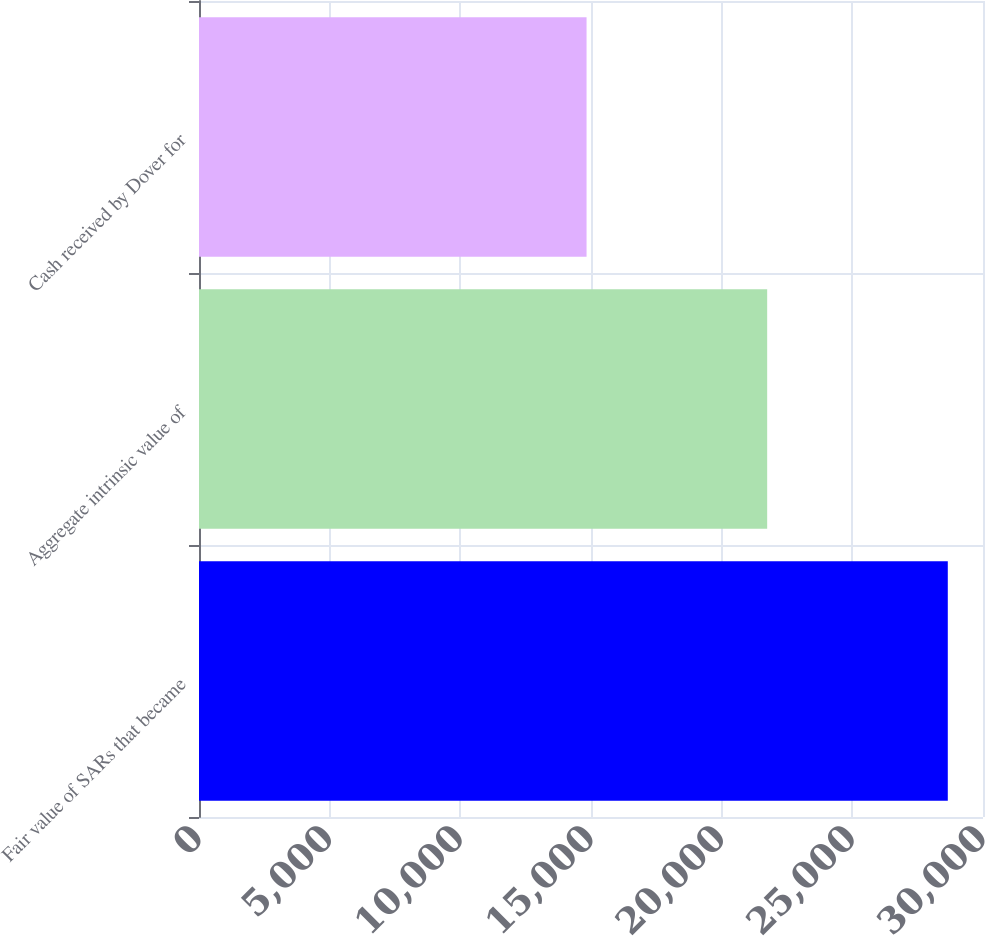Convert chart to OTSL. <chart><loc_0><loc_0><loc_500><loc_500><bar_chart><fcel>Fair value of SARs that became<fcel>Aggregate intrinsic value of<fcel>Cash received by Dover for<nl><fcel>28652.8<fcel>21741.4<fcel>14830<nl></chart> 